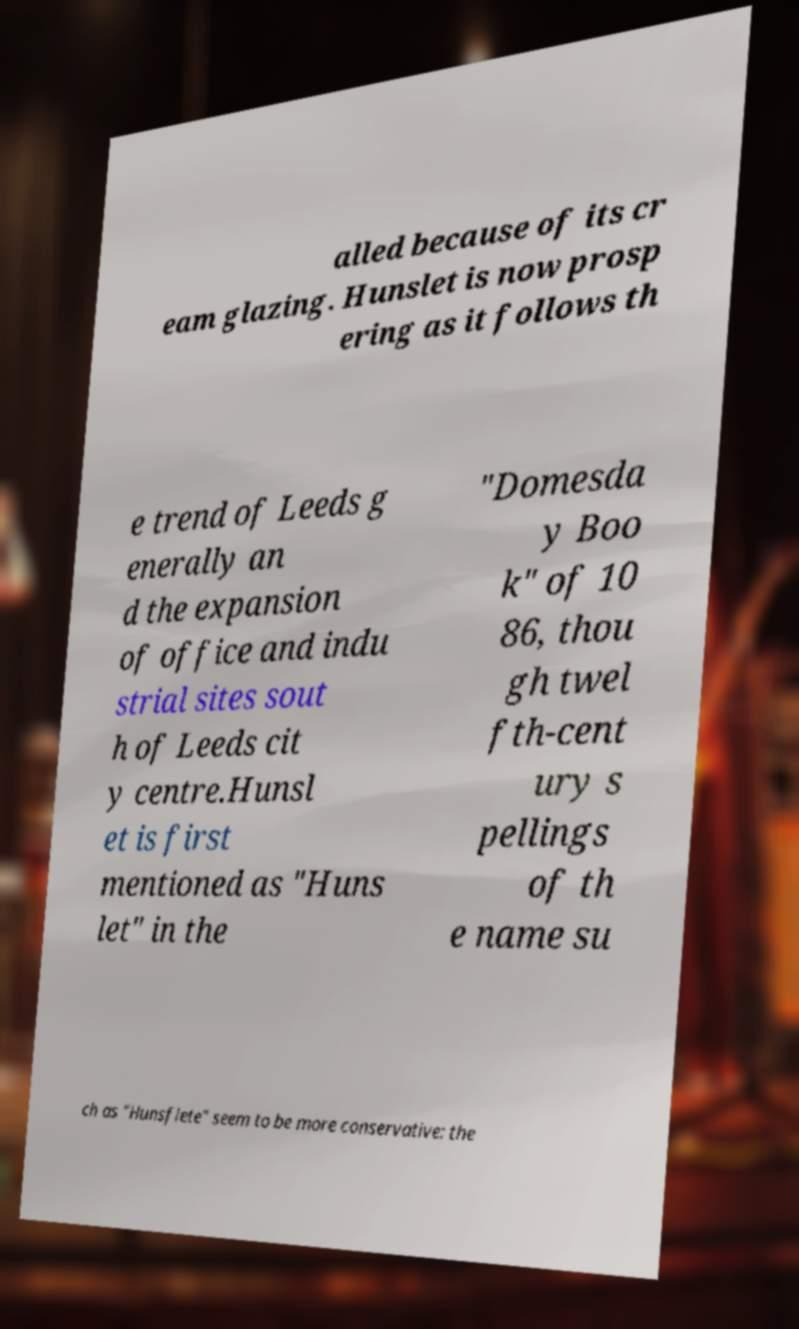Please identify and transcribe the text found in this image. alled because of its cr eam glazing. Hunslet is now prosp ering as it follows th e trend of Leeds g enerally an d the expansion of office and indu strial sites sout h of Leeds cit y centre.Hunsl et is first mentioned as "Huns let" in the "Domesda y Boo k" of 10 86, thou gh twel fth-cent ury s pellings of th e name su ch as "Hunsflete" seem to be more conservative: the 